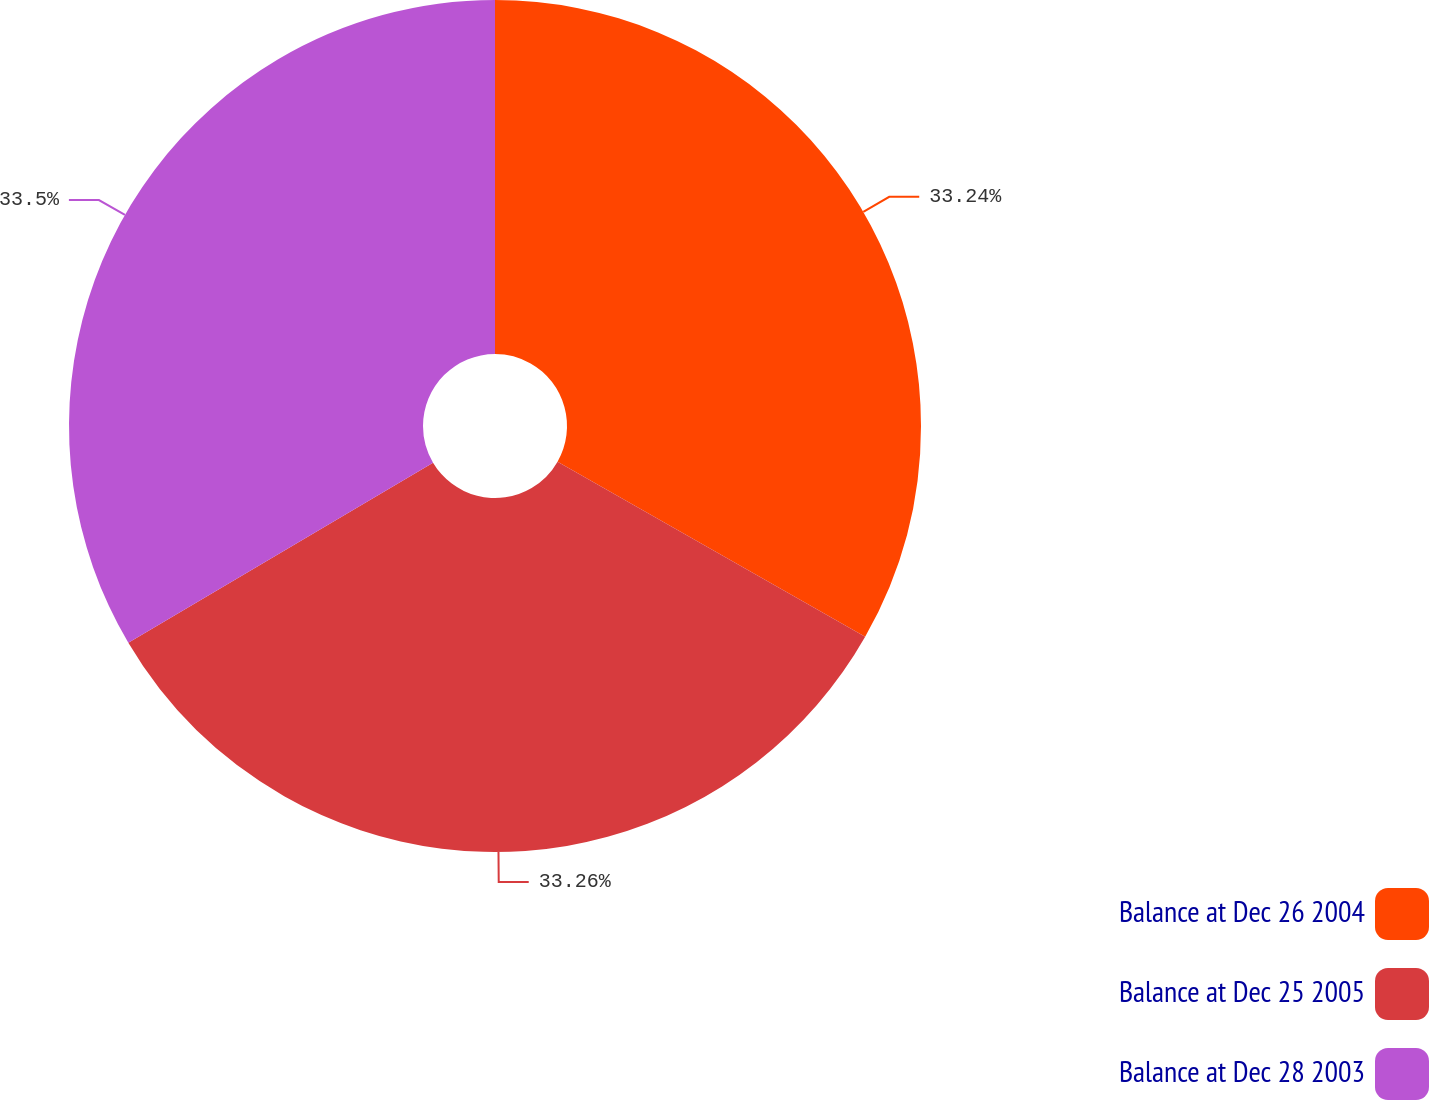<chart> <loc_0><loc_0><loc_500><loc_500><pie_chart><fcel>Balance at Dec 26 2004<fcel>Balance at Dec 25 2005<fcel>Balance at Dec 28 2003<nl><fcel>33.24%<fcel>33.26%<fcel>33.5%<nl></chart> 